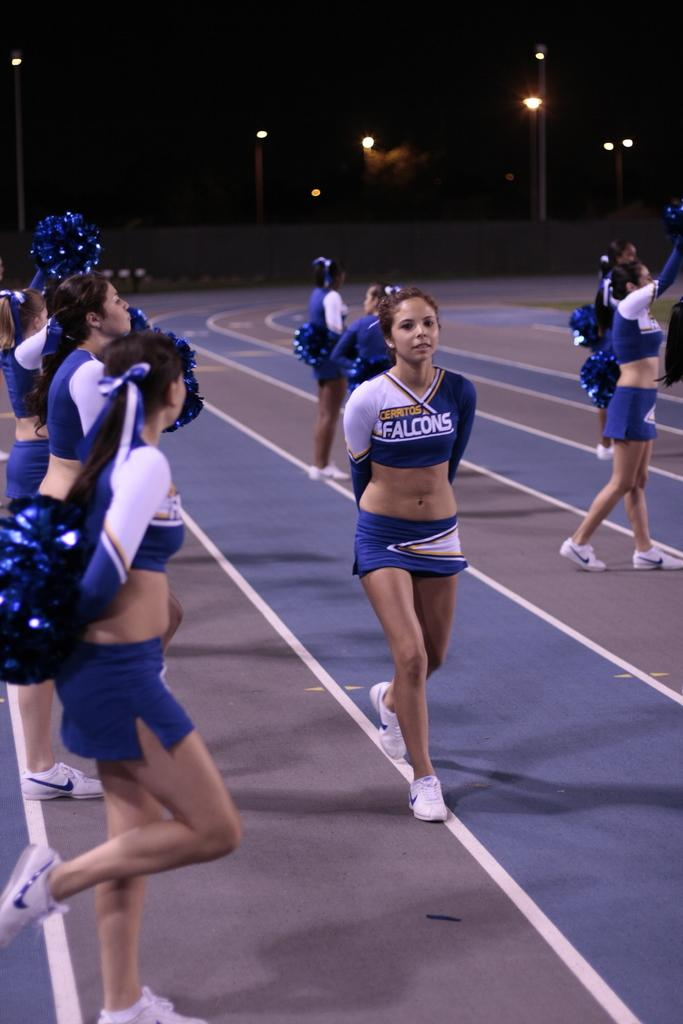Provide a one-sentence caption for the provided image. Cerritos Falcons Cheerleaders cheering for a sports game on the track. 